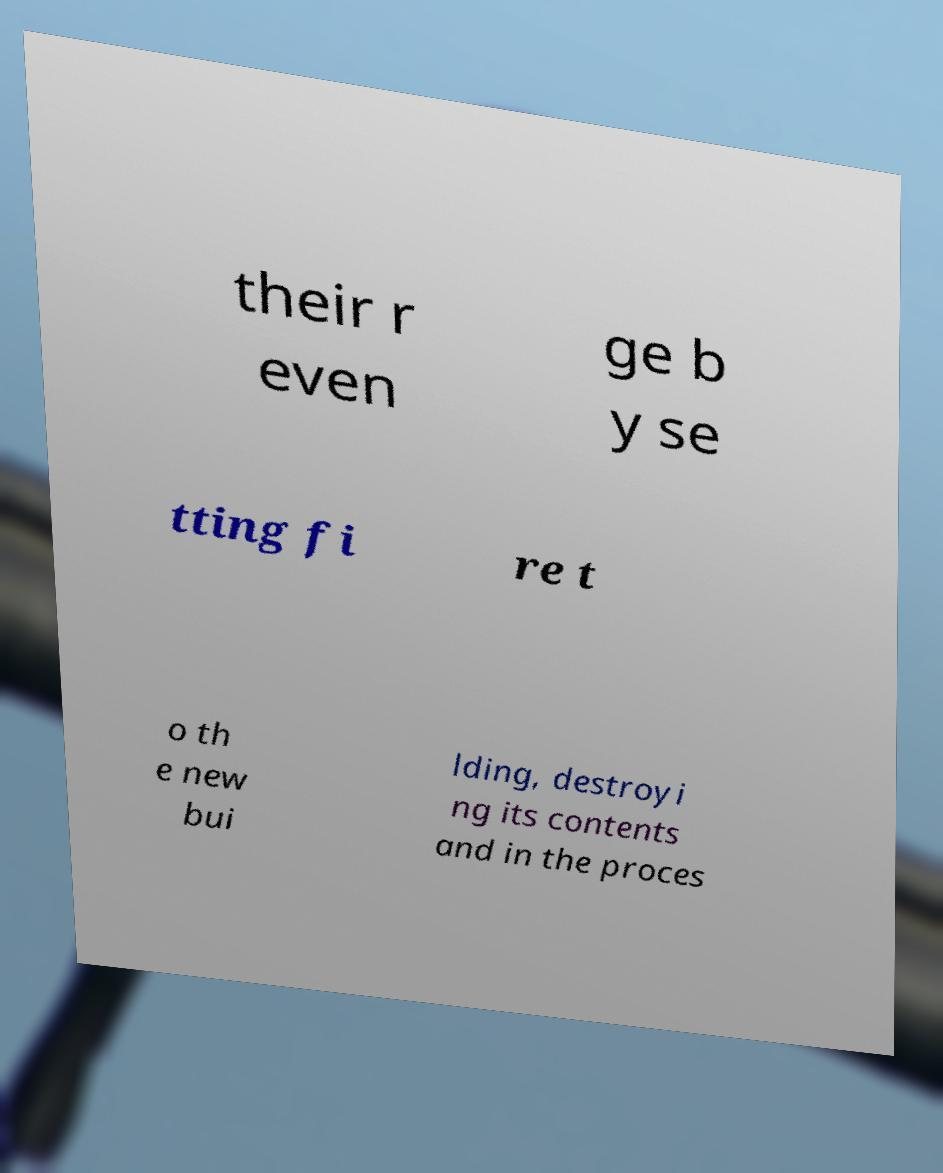Can you read and provide the text displayed in the image?This photo seems to have some interesting text. Can you extract and type it out for me? their r even ge b y se tting fi re t o th e new bui lding, destroyi ng its contents and in the proces 